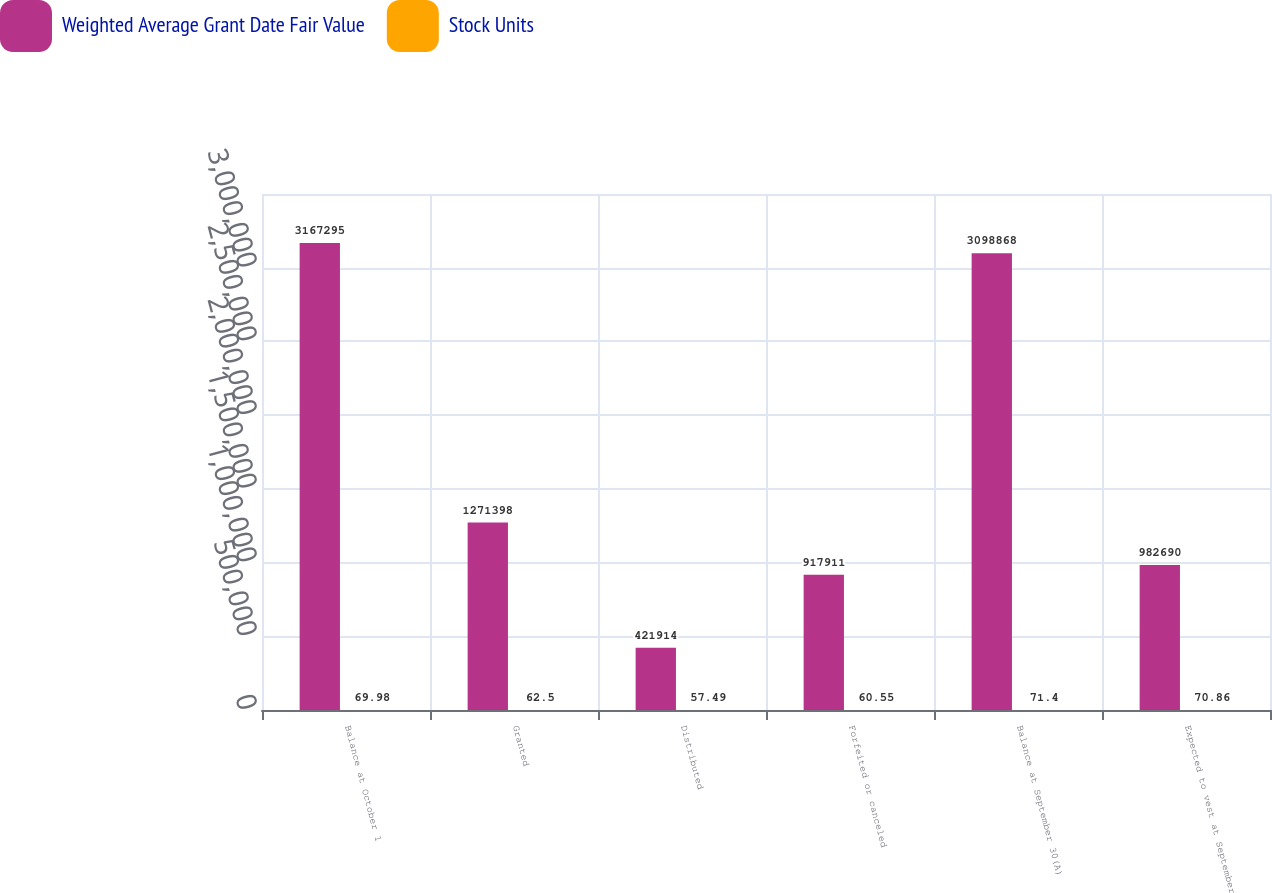Convert chart. <chart><loc_0><loc_0><loc_500><loc_500><stacked_bar_chart><ecel><fcel>Balance at October 1<fcel>Granted<fcel>Distributed<fcel>Forfeited or canceled<fcel>Balance at September 30(A)<fcel>Expected to vest at September<nl><fcel>Weighted Average Grant Date Fair Value<fcel>3.1673e+06<fcel>1.2714e+06<fcel>421914<fcel>917911<fcel>3.09887e+06<fcel>982690<nl><fcel>Stock Units<fcel>69.98<fcel>62.5<fcel>57.49<fcel>60.55<fcel>71.4<fcel>70.86<nl></chart> 